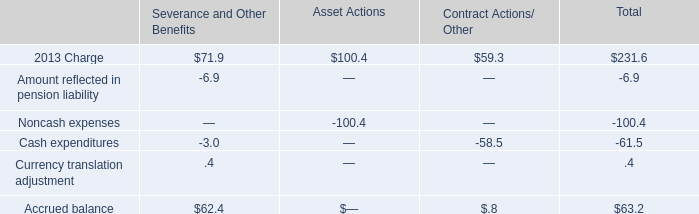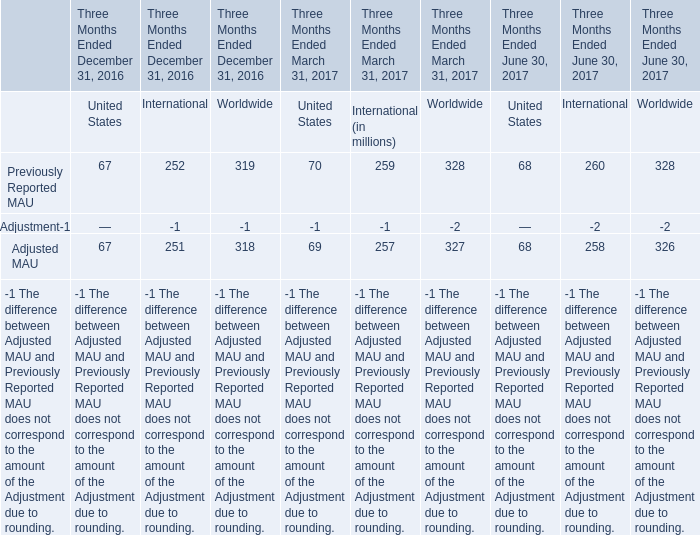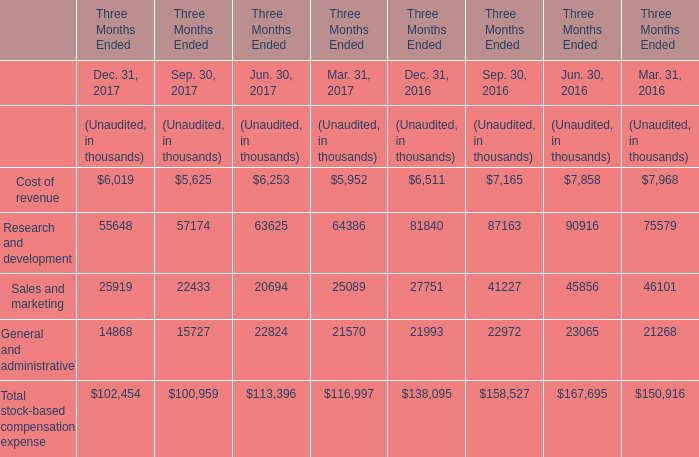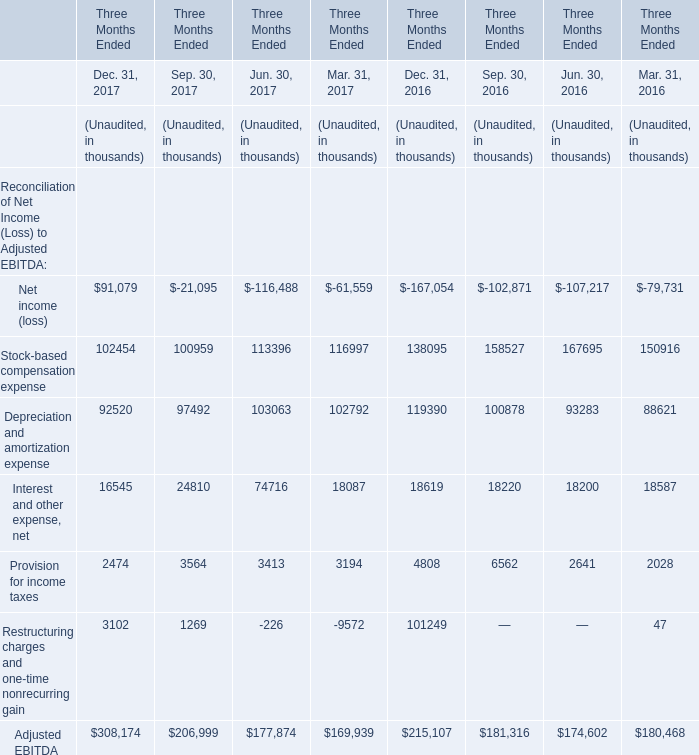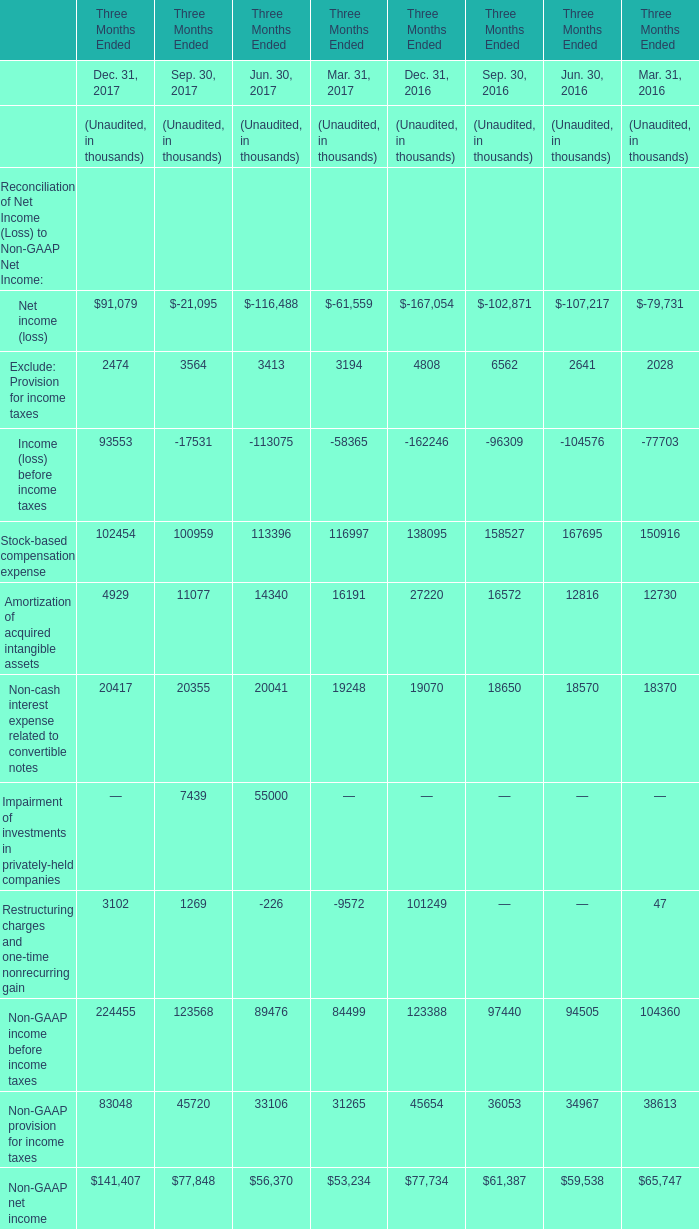What's the increasing rate of Interest and other expense, net in Dec. 31, 2017? 
Computations: ((16545 - 18619) / 18619)
Answer: -0.11139. 